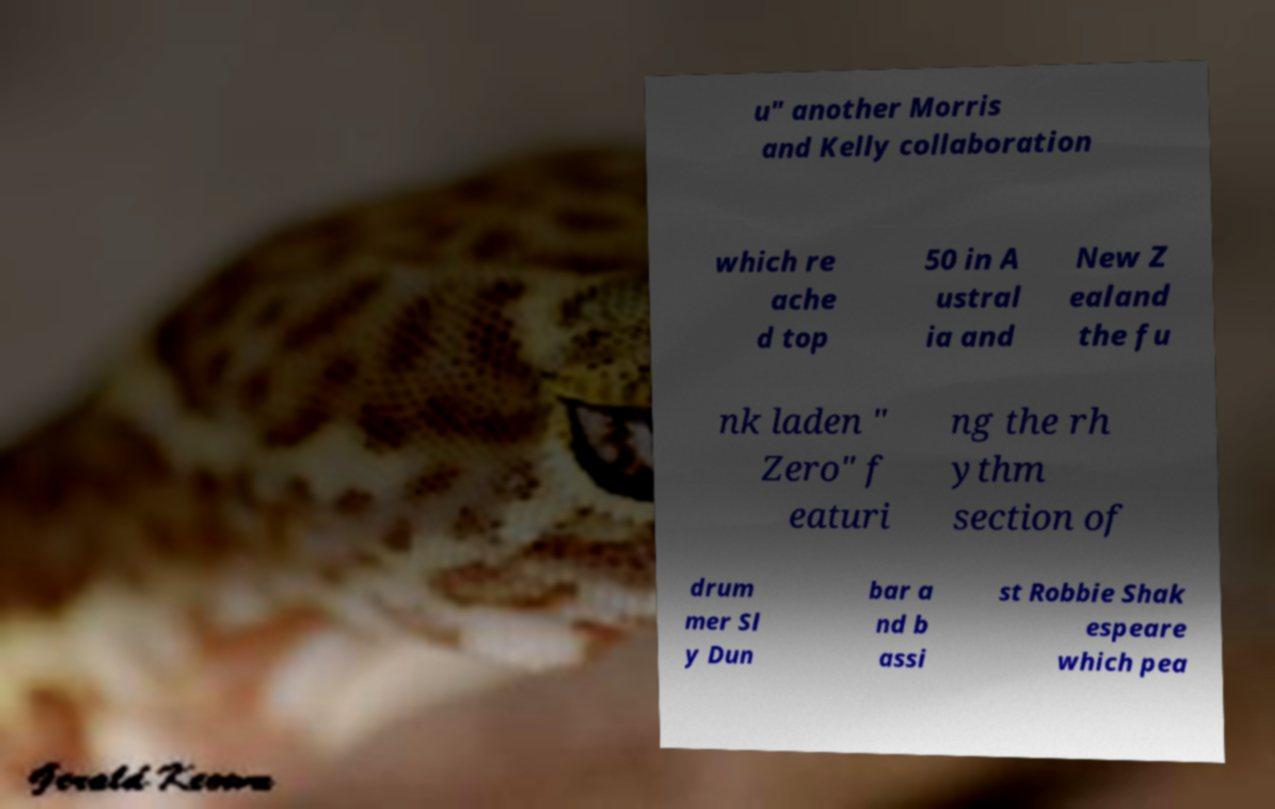Please read and relay the text visible in this image. What does it say? u" another Morris and Kelly collaboration which re ache d top 50 in A ustral ia and New Z ealand the fu nk laden " Zero" f eaturi ng the rh ythm section of drum mer Sl y Dun bar a nd b assi st Robbie Shak espeare which pea 